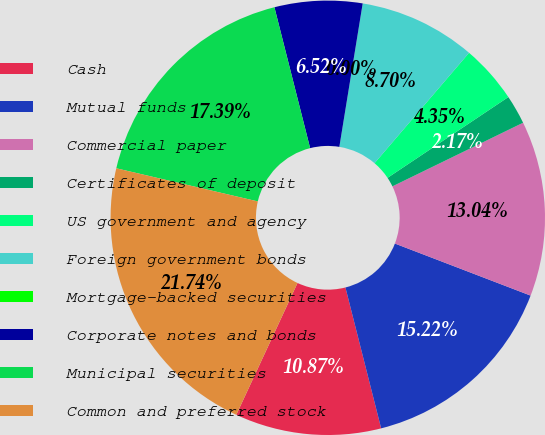Convert chart to OTSL. <chart><loc_0><loc_0><loc_500><loc_500><pie_chart><fcel>Cash<fcel>Mutual funds<fcel>Commercial paper<fcel>Certificates of deposit<fcel>US government and agency<fcel>Foreign government bonds<fcel>Mortgage-backed securities<fcel>Corporate notes and bonds<fcel>Municipal securities<fcel>Common and preferred stock<nl><fcel>10.87%<fcel>15.22%<fcel>13.04%<fcel>2.17%<fcel>4.35%<fcel>8.7%<fcel>0.0%<fcel>6.52%<fcel>17.39%<fcel>21.74%<nl></chart> 